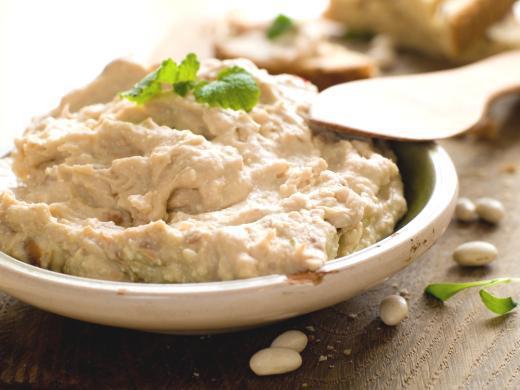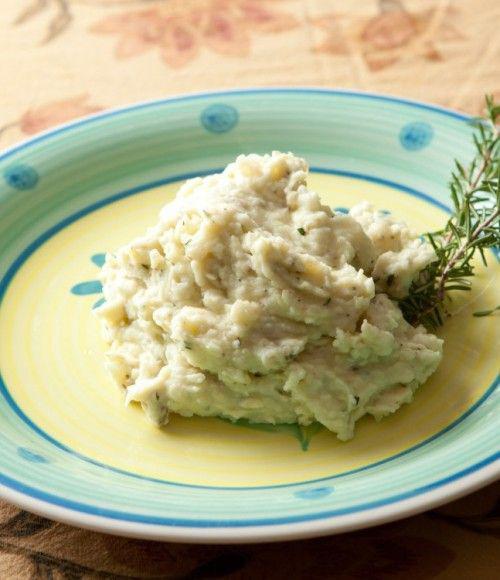The first image is the image on the left, the second image is the image on the right. Evaluate the accuracy of this statement regarding the images: "A spoon sits by the food in one of the images.". Is it true? Answer yes or no. Yes. 